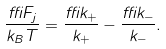<formula> <loc_0><loc_0><loc_500><loc_500>\frac { \delta F _ { j } } { k _ { B } T } = \frac { \delta k _ { + } } { k _ { + } } - \frac { \delta k _ { - } } { k _ { - } } .</formula> 